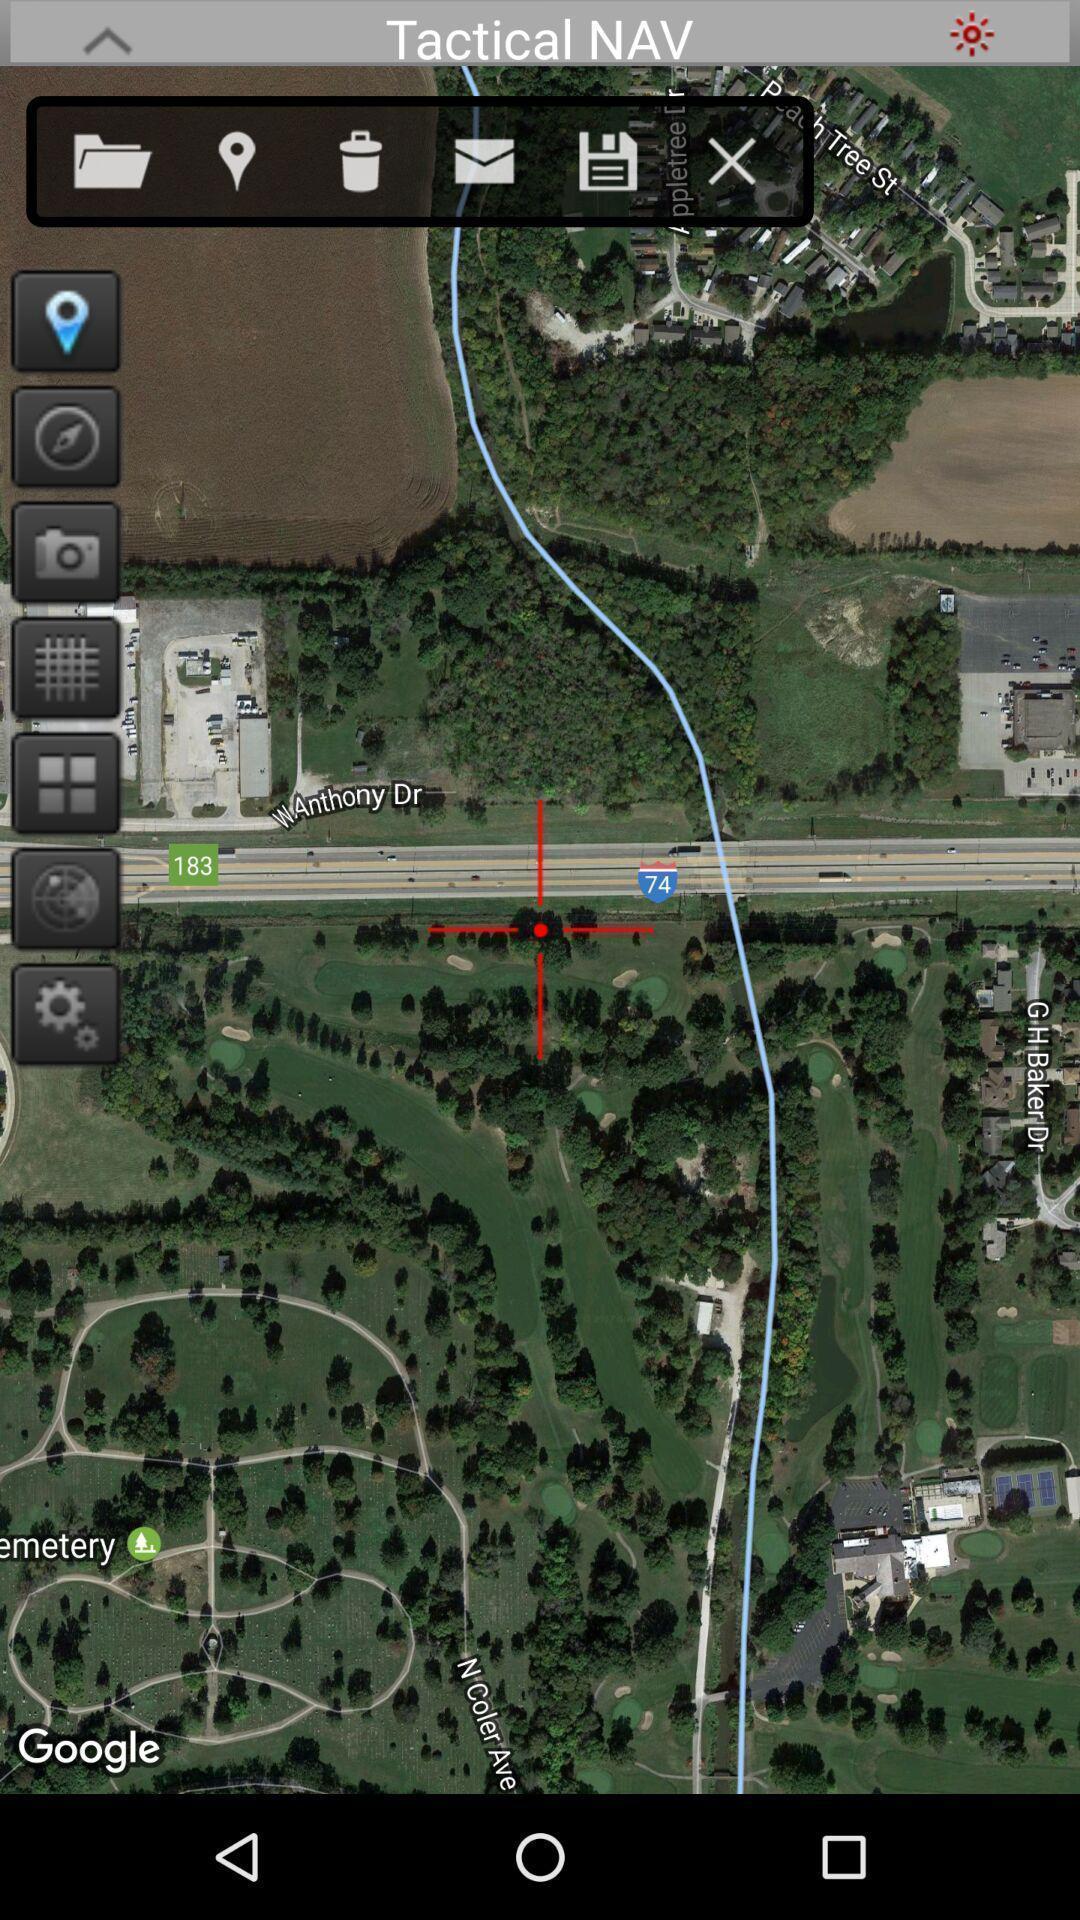Provide a description of this screenshot. Satellite view of the place. 